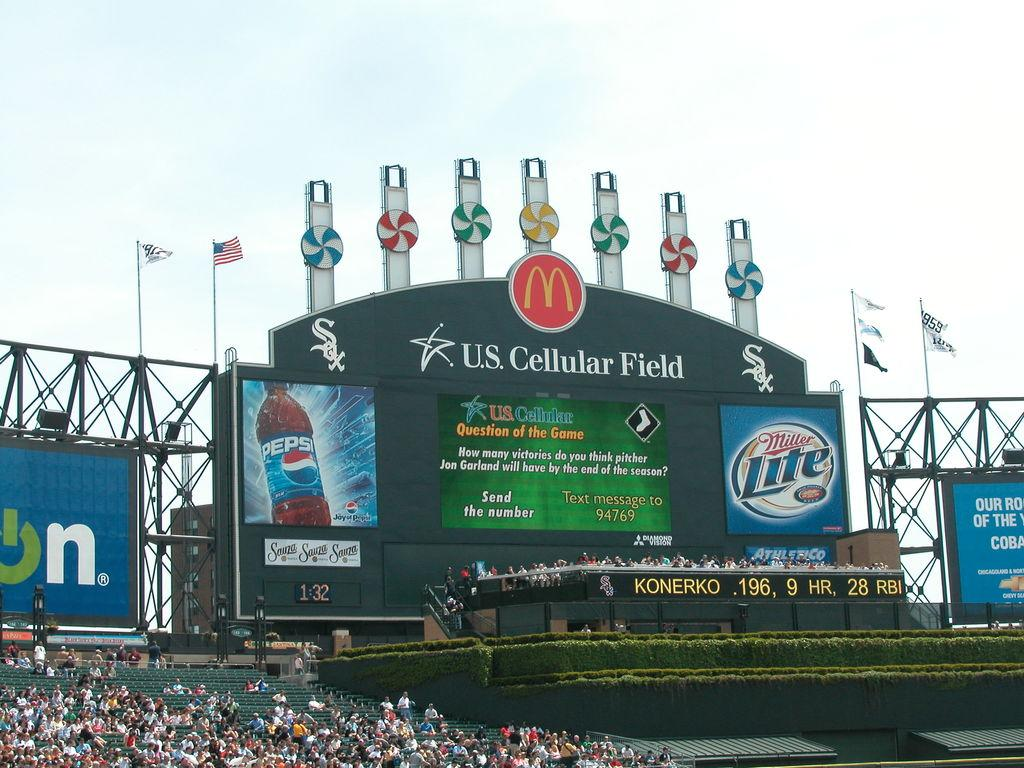<image>
Write a terse but informative summary of the picture. A crowd in front of a stage which has US Cellular Field written on it. 